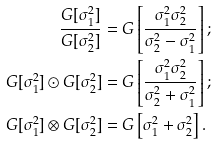<formula> <loc_0><loc_0><loc_500><loc_500>\frac { G [ \sigma ^ { 2 } _ { 1 } ] } { G [ \sigma ^ { 2 } _ { 2 } ] } & = G \left [ \frac { \sigma ^ { 2 } _ { 1 } \sigma ^ { 2 } _ { 2 } } { \sigma ^ { 2 } _ { 2 } - \sigma ^ { 2 } _ { 1 } } \right ] ; \\ G [ \sigma ^ { 2 } _ { 1 } ] \odot G [ \sigma ^ { 2 } _ { 2 } ] & = G \left [ \frac { \sigma ^ { 2 } _ { 1 } \sigma ^ { 2 } _ { 2 } } { \sigma ^ { 2 } _ { 2 } + \sigma ^ { 2 } _ { 1 } } \right ] ; \\ G [ \sigma ^ { 2 } _ { 1 } ] \otimes G [ \sigma ^ { 2 } _ { 2 } ] & = G \left [ \sigma ^ { 2 } _ { 1 } + \sigma ^ { 2 } _ { 2 } \right ] .</formula> 